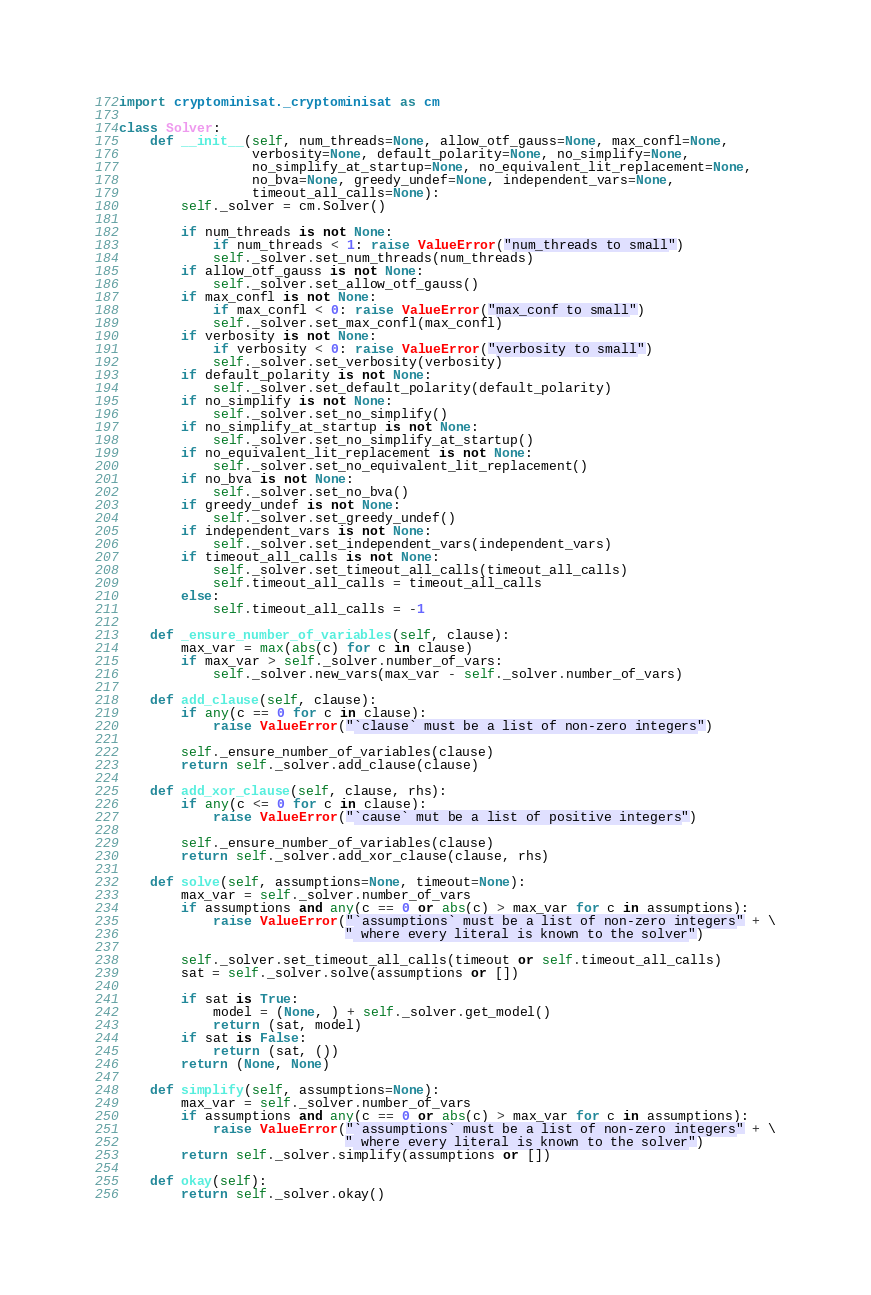<code> <loc_0><loc_0><loc_500><loc_500><_Python_>import cryptominisat._cryptominisat as cm

class Solver:
    def __init__(self, num_threads=None, allow_otf_gauss=None, max_confl=None,
                 verbosity=None, default_polarity=None, no_simplify=None,
                 no_simplify_at_startup=None, no_equivalent_lit_replacement=None,
                 no_bva=None, greedy_undef=None, independent_vars=None,
                 timeout_all_calls=None):
        self._solver = cm.Solver()

        if num_threads is not None:
            if num_threads < 1: raise ValueError("num_threads to small")
            self._solver.set_num_threads(num_threads)
        if allow_otf_gauss is not None:
            self._solver.set_allow_otf_gauss()
        if max_confl is not None:
            if max_confl < 0: raise ValueError("max_conf to small")
            self._solver.set_max_confl(max_confl)
        if verbosity is not None:
            if verbosity < 0: raise ValueError("verbosity to small")
            self._solver.set_verbosity(verbosity)
        if default_polarity is not None:
            self._solver.set_default_polarity(default_polarity)
        if no_simplify is not None:
            self._solver.set_no_simplify()
        if no_simplify_at_startup is not None:
            self._solver.set_no_simplify_at_startup()
        if no_equivalent_lit_replacement is not None:
            self._solver.set_no_equivalent_lit_replacement()
        if no_bva is not None:
            self._solver.set_no_bva()
        if greedy_undef is not None:
            self._solver.set_greedy_undef()
        if independent_vars is not None:
            self._solver.set_independent_vars(independent_vars)
        if timeout_all_calls is not None:
            self._solver.set_timeout_all_calls(timeout_all_calls)
            self.timeout_all_calls = timeout_all_calls
        else:
            self.timeout_all_calls = -1

    def _ensure_number_of_variables(self, clause):
        max_var = max(abs(c) for c in clause)
        if max_var > self._solver.number_of_vars:
            self._solver.new_vars(max_var - self._solver.number_of_vars)

    def add_clause(self, clause):
        if any(c == 0 for c in clause):
            raise ValueError("`clause` must be a list of non-zero integers")

        self._ensure_number_of_variables(clause)
        return self._solver.add_clause(clause)

    def add_xor_clause(self, clause, rhs):
        if any(c <= 0 for c in clause):
            raise ValueError("`cause` mut be a list of positive integers")

        self._ensure_number_of_variables(clause)
        return self._solver.add_xor_clause(clause, rhs)

    def solve(self, assumptions=None, timeout=None):
        max_var = self._solver.number_of_vars
        if assumptions and any(c == 0 or abs(c) > max_var for c in assumptions):
            raise ValueError("`assumptions` must be a list of non-zero integers" + \
                             " where every literal is known to the solver")

        self._solver.set_timeout_all_calls(timeout or self.timeout_all_calls)
        sat = self._solver.solve(assumptions or [])

        if sat is True:
            model = (None, ) + self._solver.get_model()
            return (sat, model)
        if sat is False:
            return (sat, ())
        return (None, None)

    def simplify(self, assumptions=None):
        max_var = self._solver.number_of_vars
        if assumptions and any(c == 0 or abs(c) > max_var for c in assumptions):
            raise ValueError("`assumptions` must be a list of non-zero integers" + \
                             " where every literal is known to the solver")
        return self._solver.simplify(assumptions or [])

    def okay(self):
        return self._solver.okay()
</code> 